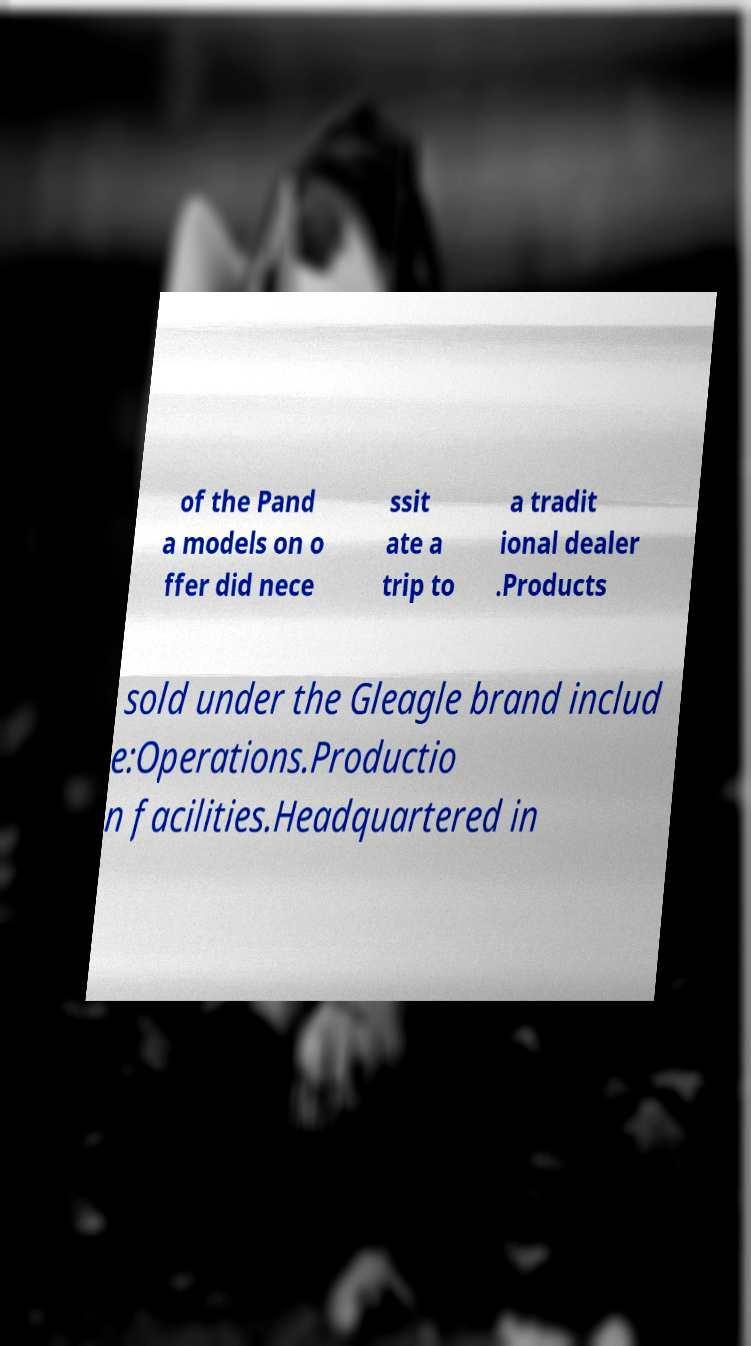What messages or text are displayed in this image? I need them in a readable, typed format. of the Pand a models on o ffer did nece ssit ate a trip to a tradit ional dealer .Products sold under the Gleagle brand includ e:Operations.Productio n facilities.Headquartered in 